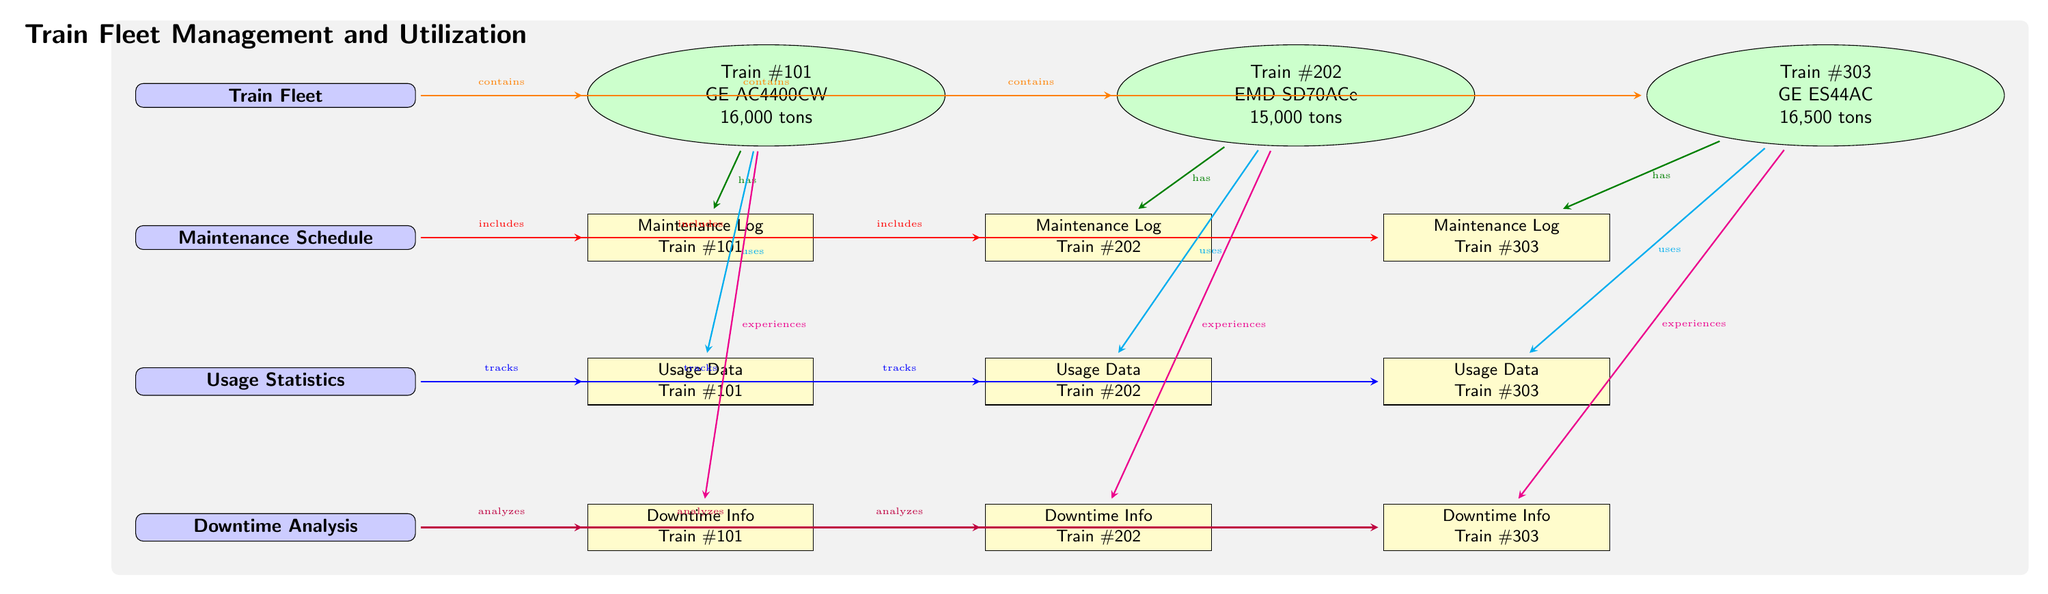What is the total number of trains in the fleet? By counting the train nodes visually in the diagram, there are three distinct trains represented: Train #101, Train #202, and Train #303.
Answer: 3 Which train has the highest tonnage? By comparing the tonnage values next to each train, Train #303 lists a tonnage of 16,500 tons, which is higher than both Train #101 and Train #202.
Answer: Train #303 What type of maintenance log does Train #202 have? The maintenance log specifically associated with Train #202 is indicated as "Maintenance Log Train #202," which is directly linked through the diagrams' arrows.
Answer: Maintenance Log Train #202 How many types of analyses are conducted in the downtime analysis section? The downtime analysis section has one link to each train's downtime info, creating a total of three distinct analyses for the three trains listed.
Answer: 3 What is the relationship between usage statistics and Train #101? The diagram shows that Train #101 "uses" the usage statistics represented in the usage section, establishing a direct connection between the two.
Answer: uses Which train experiences downtime information? The diagram explicitly states that each train experiences downtime, and specifically for Train #202, it indicates "Downtime Info Train #202."
Answer: Downtime Info Train #202 What color represents the Maintenance Schedule node? The Maintenance Schedule node is filled with a light blue shade, which is visually identifiable by its color in the diagram.
Answer: blue!20 What element connects the train fleet to the maintenance schedule? The arrow labeled "contains" indicates the connection from the Train Fleet node directly to the Maintenance Schedule node, illustrating their relationship.
Answer: contains 